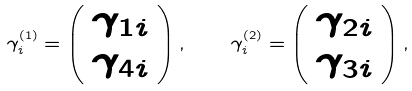<formula> <loc_0><loc_0><loc_500><loc_500>\gamma ^ { ( 1 ) } _ { i } = \left ( \begin{array} { c } \gamma _ { 1 i } \\ \gamma _ { 4 i } \end{array} \right ) , \quad \gamma ^ { ( 2 ) } _ { i } = \left ( \begin{array} { c } \gamma _ { 2 i } \\ \gamma _ { 3 i } \end{array} \right ) ,</formula> 